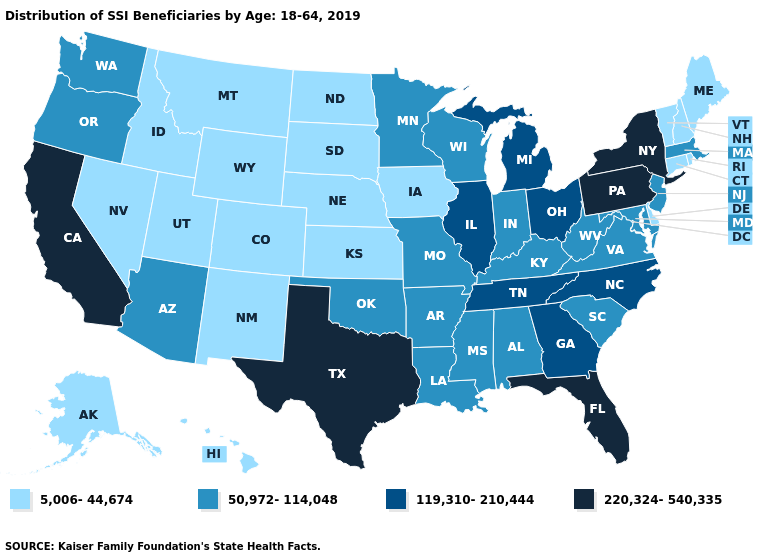What is the lowest value in the USA?
Answer briefly. 5,006-44,674. What is the highest value in the USA?
Short answer required. 220,324-540,335. What is the highest value in states that border Wisconsin?
Concise answer only. 119,310-210,444. What is the value of New Hampshire?
Keep it brief. 5,006-44,674. What is the value of Iowa?
Quick response, please. 5,006-44,674. Which states have the lowest value in the USA?
Write a very short answer. Alaska, Colorado, Connecticut, Delaware, Hawaii, Idaho, Iowa, Kansas, Maine, Montana, Nebraska, Nevada, New Hampshire, New Mexico, North Dakota, Rhode Island, South Dakota, Utah, Vermont, Wyoming. Among the states that border Georgia , does North Carolina have the highest value?
Short answer required. No. Name the states that have a value in the range 5,006-44,674?
Be succinct. Alaska, Colorado, Connecticut, Delaware, Hawaii, Idaho, Iowa, Kansas, Maine, Montana, Nebraska, Nevada, New Hampshire, New Mexico, North Dakota, Rhode Island, South Dakota, Utah, Vermont, Wyoming. Among the states that border Minnesota , which have the highest value?
Give a very brief answer. Wisconsin. What is the value of New Jersey?
Quick response, please. 50,972-114,048. How many symbols are there in the legend?
Be succinct. 4. Name the states that have a value in the range 5,006-44,674?
Be succinct. Alaska, Colorado, Connecticut, Delaware, Hawaii, Idaho, Iowa, Kansas, Maine, Montana, Nebraska, Nevada, New Hampshire, New Mexico, North Dakota, Rhode Island, South Dakota, Utah, Vermont, Wyoming. Does Illinois have the same value as Tennessee?
Give a very brief answer. Yes. What is the lowest value in the USA?
Concise answer only. 5,006-44,674. What is the lowest value in states that border Arkansas?
Be succinct. 50,972-114,048. 